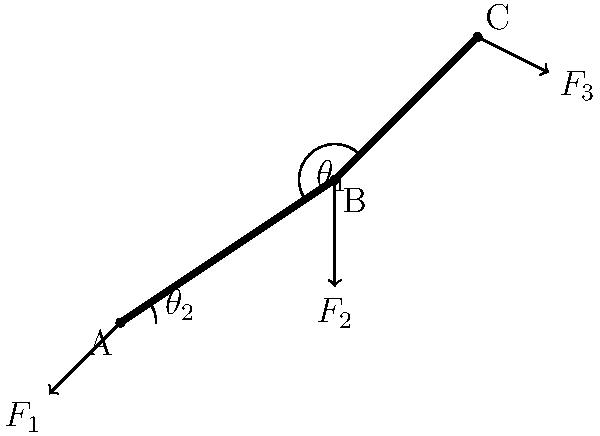As a charismatic TV host, you're presenting a segment on robotics. Explain to your audience how the forces $F_1$, $F_2$, and $F_3$ in this robotic arm diagram relate to each other for the system to be in equilibrium. Which force is likely the largest, and why? Let's break this down step-by-step for our audience:

1. For the robotic arm to be in equilibrium, the sum of all forces and moments must be zero.

2. We have three forces acting on the arm:
   $F_1$ at joint A (base)
   $F_2$ at joint B (middle)
   $F_3$ at joint C (end effector)

3. The force at the base ($F_1$) must counteract the combined effects of $F_2$ and $F_3$.

4. $F_3$ is likely an external force (e.g., the weight of an object being lifted or a task being performed).

5. $F_2$ is an internal force at the middle joint, which helps distribute the load.

6. $F_1$ must balance both the vertical and horizontal components of $F_2$ and $F_3$.

7. The moment arm for $F_3$ is longer than for $F_2$, giving it more leverage.

8. Therefore, $F_1$ is likely the largest force because:
   a) It must counteract both $F_2$ and $F_3$
   b) It needs to balance both vertical and horizontal components
   c) It's fighting against the leverage advantage of $F_3$

In summary, $F_1$ is probably the largest force to maintain equilibrium, as it's doing the "heavy lifting" to keep the entire arm stable while counteracting the other forces and their moments.
Answer: $F_1$ is likely the largest force, as it counteracts both $F_2$ and $F_3$ while balancing their moments. 